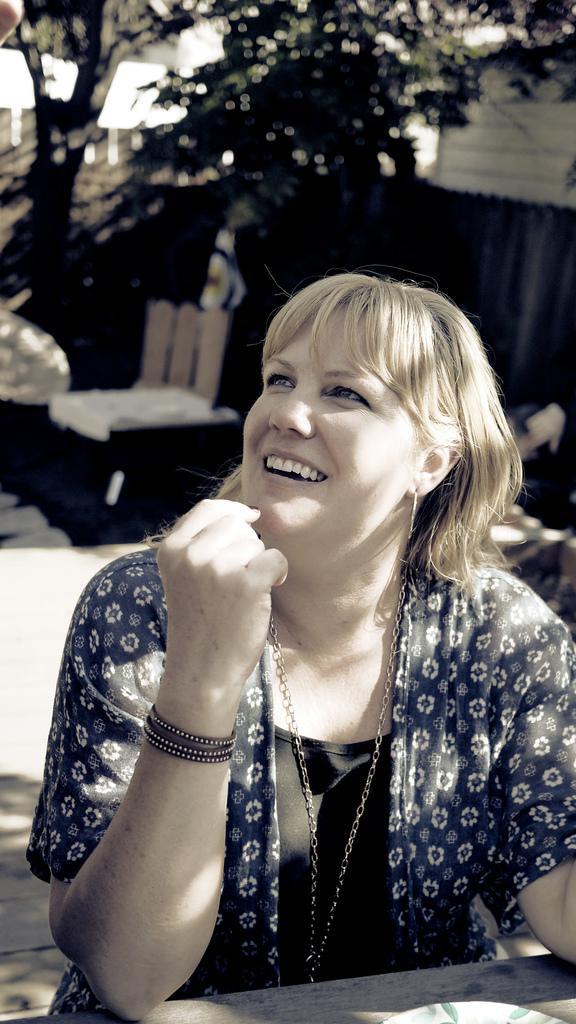Describe this image in one or two sentences. Here in this picture we can see a woman sitting over a place with table in front of her and we can see she is smiling and behind her we can see plants and trees in blurry manner and we can also see table and chair present. 